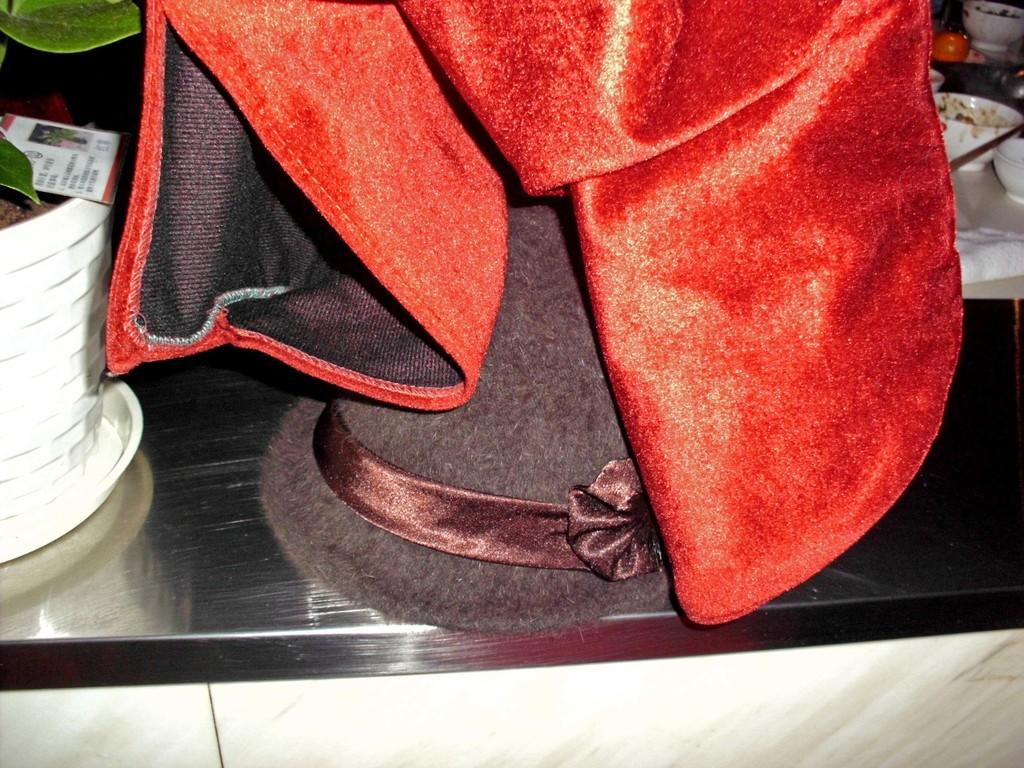What type of furniture is in the image? There is a cabinet in the image. What is placed on top of the cabinet? A hat and a plant pot are present on the cabinet. What else can be seen on the cabinet? There is a cloth on the cabinet. Are there any other objects visible in the image? Yes, there are some bowls in the image. How does the drain contribute to the comfort of the bridge in the image? There is no drain or bridge present in the image; it features a cabinet with various items on top. 